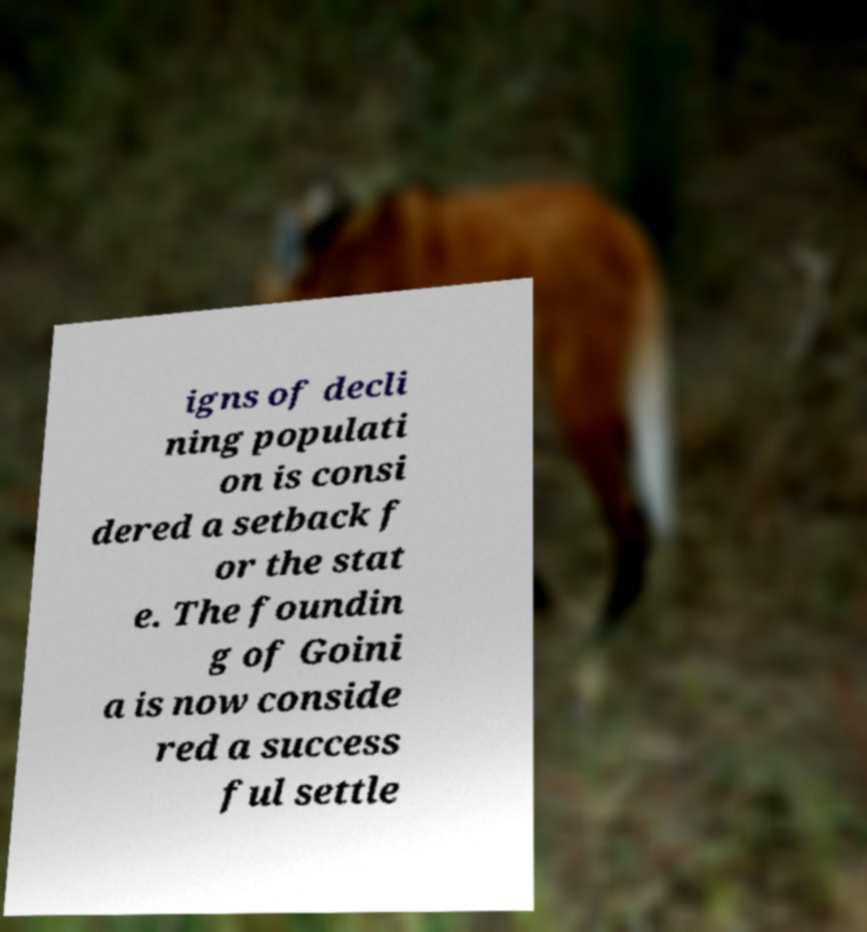Please identify and transcribe the text found in this image. igns of decli ning populati on is consi dered a setback f or the stat e. The foundin g of Goini a is now conside red a success ful settle 